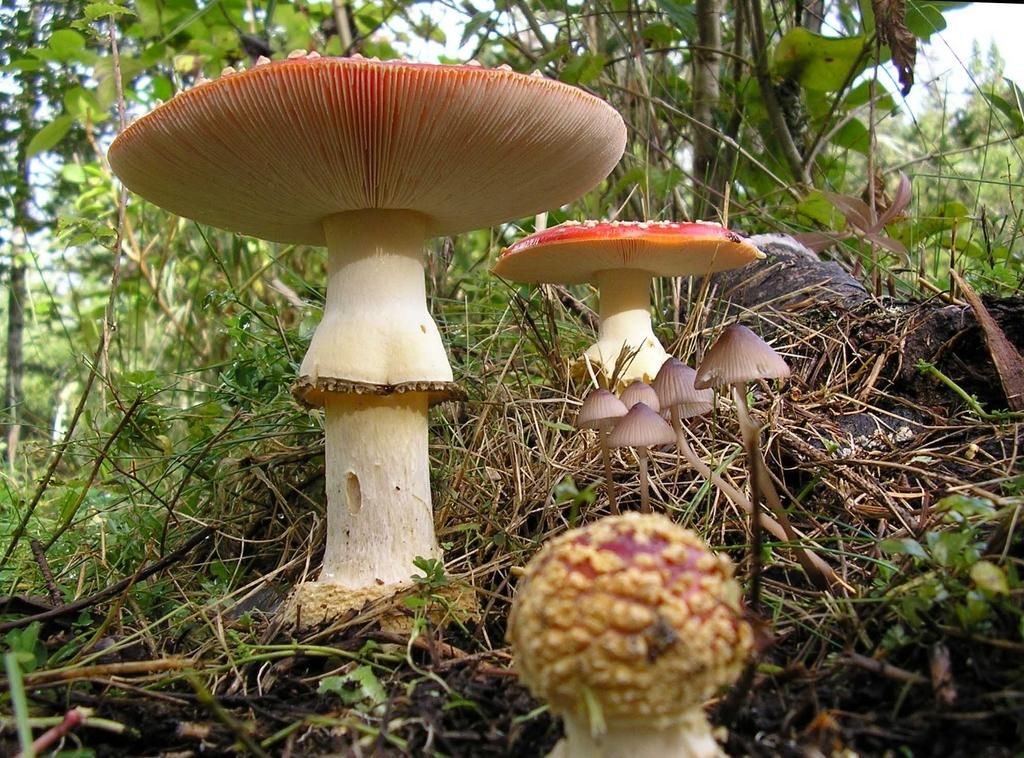What type of vegetation can be seen in the image? There are mushrooms in the ground in the image. What can be seen in the background of the image? There are trees visible in the background of the image. What type of fuel is being used by the mushrooms in the image? There is no indication in the image that the mushrooms are using any type of fuel. 